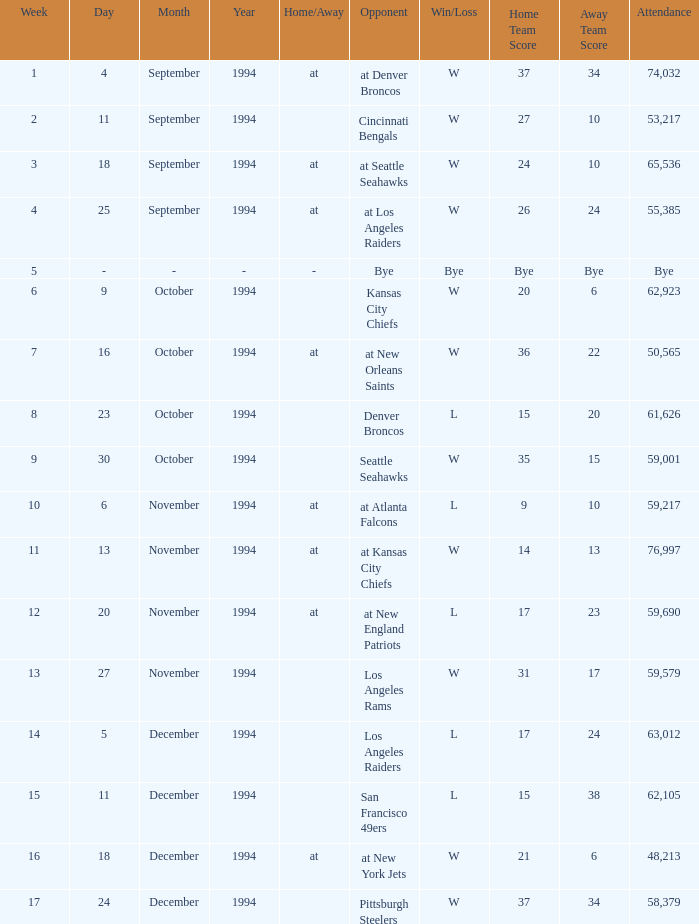In the game on or before week 9, who was the opponent when the attendance was 61,626? Denver Broncos. 